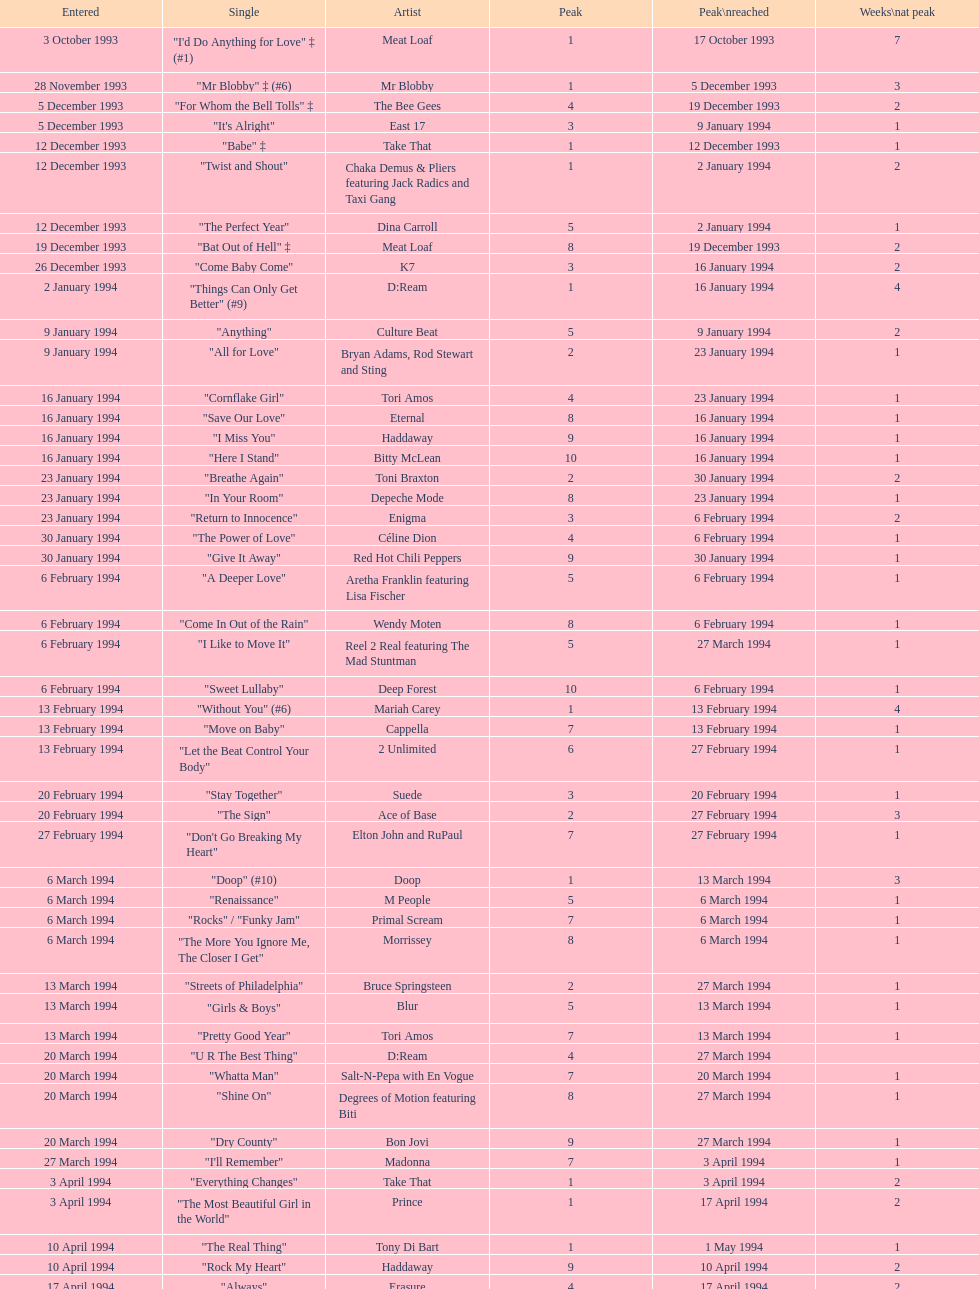This track put out by celine dion was on the uk singles chart for 17 weeks in 1994, what is its title? "Think Twice". 